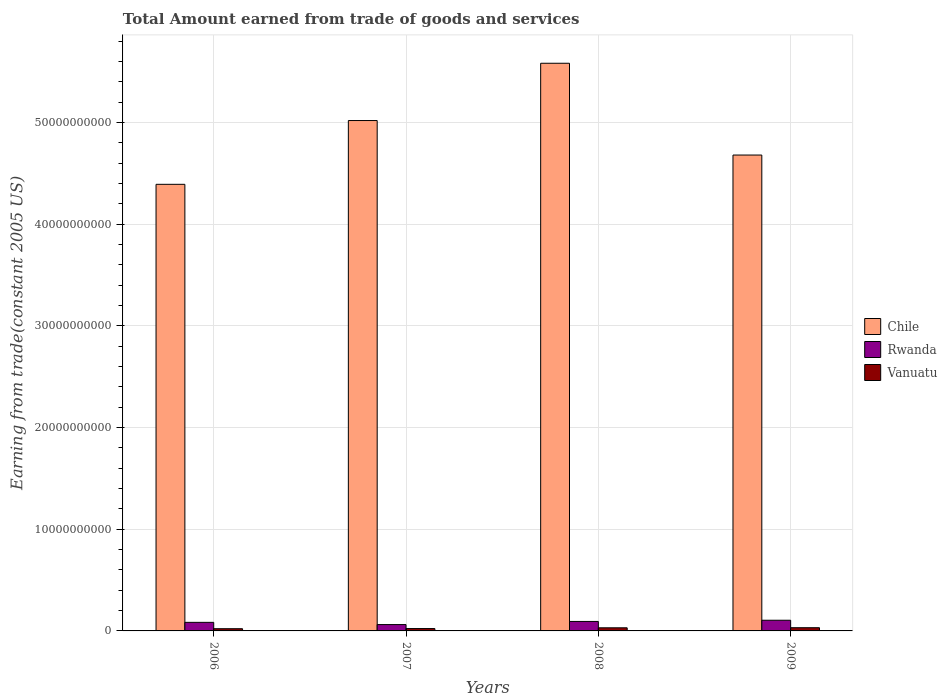How many groups of bars are there?
Ensure brevity in your answer.  4. Are the number of bars per tick equal to the number of legend labels?
Provide a short and direct response. Yes. Are the number of bars on each tick of the X-axis equal?
Keep it short and to the point. Yes. How many bars are there on the 2nd tick from the right?
Your response must be concise. 3. What is the label of the 2nd group of bars from the left?
Provide a short and direct response. 2007. In how many cases, is the number of bars for a given year not equal to the number of legend labels?
Your response must be concise. 0. What is the total amount earned by trading goods and services in Vanuatu in 2009?
Ensure brevity in your answer.  3.15e+08. Across all years, what is the maximum total amount earned by trading goods and services in Rwanda?
Make the answer very short. 1.05e+09. Across all years, what is the minimum total amount earned by trading goods and services in Vanuatu?
Your response must be concise. 2.18e+08. In which year was the total amount earned by trading goods and services in Chile maximum?
Ensure brevity in your answer.  2008. In which year was the total amount earned by trading goods and services in Chile minimum?
Provide a short and direct response. 2006. What is the total total amount earned by trading goods and services in Rwanda in the graph?
Ensure brevity in your answer.  3.45e+09. What is the difference between the total amount earned by trading goods and services in Chile in 2006 and that in 2009?
Offer a terse response. -2.88e+09. What is the difference between the total amount earned by trading goods and services in Chile in 2007 and the total amount earned by trading goods and services in Rwanda in 2009?
Offer a terse response. 4.92e+1. What is the average total amount earned by trading goods and services in Chile per year?
Your answer should be compact. 4.92e+1. In the year 2008, what is the difference between the total amount earned by trading goods and services in Vanuatu and total amount earned by trading goods and services in Chile?
Offer a very short reply. -5.55e+1. What is the ratio of the total amount earned by trading goods and services in Vanuatu in 2006 to that in 2009?
Offer a very short reply. 0.69. Is the total amount earned by trading goods and services in Rwanda in 2006 less than that in 2007?
Provide a succinct answer. No. Is the difference between the total amount earned by trading goods and services in Vanuatu in 2007 and 2008 greater than the difference between the total amount earned by trading goods and services in Chile in 2007 and 2008?
Keep it short and to the point. Yes. What is the difference between the highest and the second highest total amount earned by trading goods and services in Chile?
Make the answer very short. 5.63e+09. What is the difference between the highest and the lowest total amount earned by trading goods and services in Vanuatu?
Your response must be concise. 9.78e+07. What does the 1st bar from the left in 2006 represents?
Keep it short and to the point. Chile. What does the 2nd bar from the right in 2009 represents?
Your answer should be compact. Rwanda. Is it the case that in every year, the sum of the total amount earned by trading goods and services in Rwanda and total amount earned by trading goods and services in Chile is greater than the total amount earned by trading goods and services in Vanuatu?
Ensure brevity in your answer.  Yes. How many years are there in the graph?
Offer a terse response. 4. Are the values on the major ticks of Y-axis written in scientific E-notation?
Make the answer very short. No. Does the graph contain any zero values?
Provide a short and direct response. No. How are the legend labels stacked?
Offer a very short reply. Vertical. What is the title of the graph?
Provide a short and direct response. Total Amount earned from trade of goods and services. Does "St. Vincent and the Grenadines" appear as one of the legend labels in the graph?
Provide a succinct answer. No. What is the label or title of the Y-axis?
Provide a short and direct response. Earning from trade(constant 2005 US). What is the Earning from trade(constant 2005 US) in Chile in 2006?
Offer a terse response. 4.39e+1. What is the Earning from trade(constant 2005 US) in Rwanda in 2006?
Your answer should be compact. 8.42e+08. What is the Earning from trade(constant 2005 US) of Vanuatu in 2006?
Ensure brevity in your answer.  2.18e+08. What is the Earning from trade(constant 2005 US) of Chile in 2007?
Give a very brief answer. 5.02e+1. What is the Earning from trade(constant 2005 US) of Rwanda in 2007?
Offer a very short reply. 6.24e+08. What is the Earning from trade(constant 2005 US) in Vanuatu in 2007?
Make the answer very short. 2.33e+08. What is the Earning from trade(constant 2005 US) in Chile in 2008?
Give a very brief answer. 5.58e+1. What is the Earning from trade(constant 2005 US) of Rwanda in 2008?
Keep it short and to the point. 9.32e+08. What is the Earning from trade(constant 2005 US) in Vanuatu in 2008?
Provide a short and direct response. 3.06e+08. What is the Earning from trade(constant 2005 US) of Chile in 2009?
Offer a very short reply. 4.68e+1. What is the Earning from trade(constant 2005 US) in Rwanda in 2009?
Give a very brief answer. 1.05e+09. What is the Earning from trade(constant 2005 US) in Vanuatu in 2009?
Your answer should be very brief. 3.15e+08. Across all years, what is the maximum Earning from trade(constant 2005 US) of Chile?
Provide a short and direct response. 5.58e+1. Across all years, what is the maximum Earning from trade(constant 2005 US) in Rwanda?
Give a very brief answer. 1.05e+09. Across all years, what is the maximum Earning from trade(constant 2005 US) of Vanuatu?
Offer a very short reply. 3.15e+08. Across all years, what is the minimum Earning from trade(constant 2005 US) in Chile?
Your response must be concise. 4.39e+1. Across all years, what is the minimum Earning from trade(constant 2005 US) in Rwanda?
Make the answer very short. 6.24e+08. Across all years, what is the minimum Earning from trade(constant 2005 US) of Vanuatu?
Your answer should be compact. 2.18e+08. What is the total Earning from trade(constant 2005 US) in Chile in the graph?
Your response must be concise. 1.97e+11. What is the total Earning from trade(constant 2005 US) in Rwanda in the graph?
Keep it short and to the point. 3.45e+09. What is the total Earning from trade(constant 2005 US) in Vanuatu in the graph?
Your response must be concise. 1.07e+09. What is the difference between the Earning from trade(constant 2005 US) in Chile in 2006 and that in 2007?
Keep it short and to the point. -6.27e+09. What is the difference between the Earning from trade(constant 2005 US) of Rwanda in 2006 and that in 2007?
Make the answer very short. 2.18e+08. What is the difference between the Earning from trade(constant 2005 US) in Vanuatu in 2006 and that in 2007?
Offer a very short reply. -1.54e+07. What is the difference between the Earning from trade(constant 2005 US) of Chile in 2006 and that in 2008?
Your answer should be very brief. -1.19e+1. What is the difference between the Earning from trade(constant 2005 US) in Rwanda in 2006 and that in 2008?
Make the answer very short. -8.99e+07. What is the difference between the Earning from trade(constant 2005 US) of Vanuatu in 2006 and that in 2008?
Give a very brief answer. -8.87e+07. What is the difference between the Earning from trade(constant 2005 US) of Chile in 2006 and that in 2009?
Give a very brief answer. -2.88e+09. What is the difference between the Earning from trade(constant 2005 US) in Rwanda in 2006 and that in 2009?
Offer a terse response. -2.09e+08. What is the difference between the Earning from trade(constant 2005 US) in Vanuatu in 2006 and that in 2009?
Offer a very short reply. -9.78e+07. What is the difference between the Earning from trade(constant 2005 US) in Chile in 2007 and that in 2008?
Make the answer very short. -5.63e+09. What is the difference between the Earning from trade(constant 2005 US) in Rwanda in 2007 and that in 2008?
Your response must be concise. -3.08e+08. What is the difference between the Earning from trade(constant 2005 US) in Vanuatu in 2007 and that in 2008?
Give a very brief answer. -7.33e+07. What is the difference between the Earning from trade(constant 2005 US) of Chile in 2007 and that in 2009?
Your answer should be compact. 3.39e+09. What is the difference between the Earning from trade(constant 2005 US) of Rwanda in 2007 and that in 2009?
Offer a very short reply. -4.27e+08. What is the difference between the Earning from trade(constant 2005 US) in Vanuatu in 2007 and that in 2009?
Make the answer very short. -8.23e+07. What is the difference between the Earning from trade(constant 2005 US) of Chile in 2008 and that in 2009?
Your answer should be very brief. 9.03e+09. What is the difference between the Earning from trade(constant 2005 US) in Rwanda in 2008 and that in 2009?
Provide a succinct answer. -1.19e+08. What is the difference between the Earning from trade(constant 2005 US) in Vanuatu in 2008 and that in 2009?
Offer a terse response. -9.04e+06. What is the difference between the Earning from trade(constant 2005 US) in Chile in 2006 and the Earning from trade(constant 2005 US) in Rwanda in 2007?
Give a very brief answer. 4.33e+1. What is the difference between the Earning from trade(constant 2005 US) of Chile in 2006 and the Earning from trade(constant 2005 US) of Vanuatu in 2007?
Your response must be concise. 4.37e+1. What is the difference between the Earning from trade(constant 2005 US) of Rwanda in 2006 and the Earning from trade(constant 2005 US) of Vanuatu in 2007?
Make the answer very short. 6.09e+08. What is the difference between the Earning from trade(constant 2005 US) in Chile in 2006 and the Earning from trade(constant 2005 US) in Rwanda in 2008?
Give a very brief answer. 4.30e+1. What is the difference between the Earning from trade(constant 2005 US) in Chile in 2006 and the Earning from trade(constant 2005 US) in Vanuatu in 2008?
Offer a very short reply. 4.36e+1. What is the difference between the Earning from trade(constant 2005 US) in Rwanda in 2006 and the Earning from trade(constant 2005 US) in Vanuatu in 2008?
Keep it short and to the point. 5.36e+08. What is the difference between the Earning from trade(constant 2005 US) of Chile in 2006 and the Earning from trade(constant 2005 US) of Rwanda in 2009?
Ensure brevity in your answer.  4.29e+1. What is the difference between the Earning from trade(constant 2005 US) in Chile in 2006 and the Earning from trade(constant 2005 US) in Vanuatu in 2009?
Keep it short and to the point. 4.36e+1. What is the difference between the Earning from trade(constant 2005 US) of Rwanda in 2006 and the Earning from trade(constant 2005 US) of Vanuatu in 2009?
Your response must be concise. 5.27e+08. What is the difference between the Earning from trade(constant 2005 US) in Chile in 2007 and the Earning from trade(constant 2005 US) in Rwanda in 2008?
Your answer should be compact. 4.93e+1. What is the difference between the Earning from trade(constant 2005 US) in Chile in 2007 and the Earning from trade(constant 2005 US) in Vanuatu in 2008?
Your answer should be very brief. 4.99e+1. What is the difference between the Earning from trade(constant 2005 US) in Rwanda in 2007 and the Earning from trade(constant 2005 US) in Vanuatu in 2008?
Your answer should be compact. 3.18e+08. What is the difference between the Earning from trade(constant 2005 US) in Chile in 2007 and the Earning from trade(constant 2005 US) in Rwanda in 2009?
Your answer should be compact. 4.92e+1. What is the difference between the Earning from trade(constant 2005 US) in Chile in 2007 and the Earning from trade(constant 2005 US) in Vanuatu in 2009?
Ensure brevity in your answer.  4.99e+1. What is the difference between the Earning from trade(constant 2005 US) in Rwanda in 2007 and the Earning from trade(constant 2005 US) in Vanuatu in 2009?
Your answer should be compact. 3.09e+08. What is the difference between the Earning from trade(constant 2005 US) in Chile in 2008 and the Earning from trade(constant 2005 US) in Rwanda in 2009?
Keep it short and to the point. 5.48e+1. What is the difference between the Earning from trade(constant 2005 US) of Chile in 2008 and the Earning from trade(constant 2005 US) of Vanuatu in 2009?
Your response must be concise. 5.55e+1. What is the difference between the Earning from trade(constant 2005 US) of Rwanda in 2008 and the Earning from trade(constant 2005 US) of Vanuatu in 2009?
Keep it short and to the point. 6.17e+08. What is the average Earning from trade(constant 2005 US) of Chile per year?
Make the answer very short. 4.92e+1. What is the average Earning from trade(constant 2005 US) of Rwanda per year?
Make the answer very short. 8.63e+08. What is the average Earning from trade(constant 2005 US) in Vanuatu per year?
Provide a succinct answer. 2.68e+08. In the year 2006, what is the difference between the Earning from trade(constant 2005 US) in Chile and Earning from trade(constant 2005 US) in Rwanda?
Your answer should be compact. 4.31e+1. In the year 2006, what is the difference between the Earning from trade(constant 2005 US) in Chile and Earning from trade(constant 2005 US) in Vanuatu?
Make the answer very short. 4.37e+1. In the year 2006, what is the difference between the Earning from trade(constant 2005 US) of Rwanda and Earning from trade(constant 2005 US) of Vanuatu?
Provide a short and direct response. 6.25e+08. In the year 2007, what is the difference between the Earning from trade(constant 2005 US) in Chile and Earning from trade(constant 2005 US) in Rwanda?
Your answer should be very brief. 4.96e+1. In the year 2007, what is the difference between the Earning from trade(constant 2005 US) of Chile and Earning from trade(constant 2005 US) of Vanuatu?
Your answer should be very brief. 5.00e+1. In the year 2007, what is the difference between the Earning from trade(constant 2005 US) of Rwanda and Earning from trade(constant 2005 US) of Vanuatu?
Offer a terse response. 3.91e+08. In the year 2008, what is the difference between the Earning from trade(constant 2005 US) of Chile and Earning from trade(constant 2005 US) of Rwanda?
Your answer should be very brief. 5.49e+1. In the year 2008, what is the difference between the Earning from trade(constant 2005 US) of Chile and Earning from trade(constant 2005 US) of Vanuatu?
Your answer should be very brief. 5.55e+1. In the year 2008, what is the difference between the Earning from trade(constant 2005 US) in Rwanda and Earning from trade(constant 2005 US) in Vanuatu?
Your answer should be compact. 6.26e+08. In the year 2009, what is the difference between the Earning from trade(constant 2005 US) in Chile and Earning from trade(constant 2005 US) in Rwanda?
Your answer should be compact. 4.58e+1. In the year 2009, what is the difference between the Earning from trade(constant 2005 US) of Chile and Earning from trade(constant 2005 US) of Vanuatu?
Keep it short and to the point. 4.65e+1. In the year 2009, what is the difference between the Earning from trade(constant 2005 US) of Rwanda and Earning from trade(constant 2005 US) of Vanuatu?
Provide a succinct answer. 7.36e+08. What is the ratio of the Earning from trade(constant 2005 US) of Rwanda in 2006 to that in 2007?
Make the answer very short. 1.35. What is the ratio of the Earning from trade(constant 2005 US) of Vanuatu in 2006 to that in 2007?
Your response must be concise. 0.93. What is the ratio of the Earning from trade(constant 2005 US) of Chile in 2006 to that in 2008?
Your answer should be compact. 0.79. What is the ratio of the Earning from trade(constant 2005 US) of Rwanda in 2006 to that in 2008?
Make the answer very short. 0.9. What is the ratio of the Earning from trade(constant 2005 US) in Vanuatu in 2006 to that in 2008?
Make the answer very short. 0.71. What is the ratio of the Earning from trade(constant 2005 US) of Chile in 2006 to that in 2009?
Your response must be concise. 0.94. What is the ratio of the Earning from trade(constant 2005 US) of Rwanda in 2006 to that in 2009?
Your answer should be compact. 0.8. What is the ratio of the Earning from trade(constant 2005 US) of Vanuatu in 2006 to that in 2009?
Make the answer very short. 0.69. What is the ratio of the Earning from trade(constant 2005 US) of Chile in 2007 to that in 2008?
Provide a succinct answer. 0.9. What is the ratio of the Earning from trade(constant 2005 US) of Rwanda in 2007 to that in 2008?
Your response must be concise. 0.67. What is the ratio of the Earning from trade(constant 2005 US) in Vanuatu in 2007 to that in 2008?
Your response must be concise. 0.76. What is the ratio of the Earning from trade(constant 2005 US) of Chile in 2007 to that in 2009?
Your answer should be very brief. 1.07. What is the ratio of the Earning from trade(constant 2005 US) in Rwanda in 2007 to that in 2009?
Your response must be concise. 0.59. What is the ratio of the Earning from trade(constant 2005 US) in Vanuatu in 2007 to that in 2009?
Give a very brief answer. 0.74. What is the ratio of the Earning from trade(constant 2005 US) in Chile in 2008 to that in 2009?
Your response must be concise. 1.19. What is the ratio of the Earning from trade(constant 2005 US) in Rwanda in 2008 to that in 2009?
Ensure brevity in your answer.  0.89. What is the ratio of the Earning from trade(constant 2005 US) of Vanuatu in 2008 to that in 2009?
Your answer should be compact. 0.97. What is the difference between the highest and the second highest Earning from trade(constant 2005 US) of Chile?
Offer a terse response. 5.63e+09. What is the difference between the highest and the second highest Earning from trade(constant 2005 US) in Rwanda?
Give a very brief answer. 1.19e+08. What is the difference between the highest and the second highest Earning from trade(constant 2005 US) of Vanuatu?
Offer a very short reply. 9.04e+06. What is the difference between the highest and the lowest Earning from trade(constant 2005 US) of Chile?
Provide a succinct answer. 1.19e+1. What is the difference between the highest and the lowest Earning from trade(constant 2005 US) of Rwanda?
Provide a succinct answer. 4.27e+08. What is the difference between the highest and the lowest Earning from trade(constant 2005 US) in Vanuatu?
Give a very brief answer. 9.78e+07. 